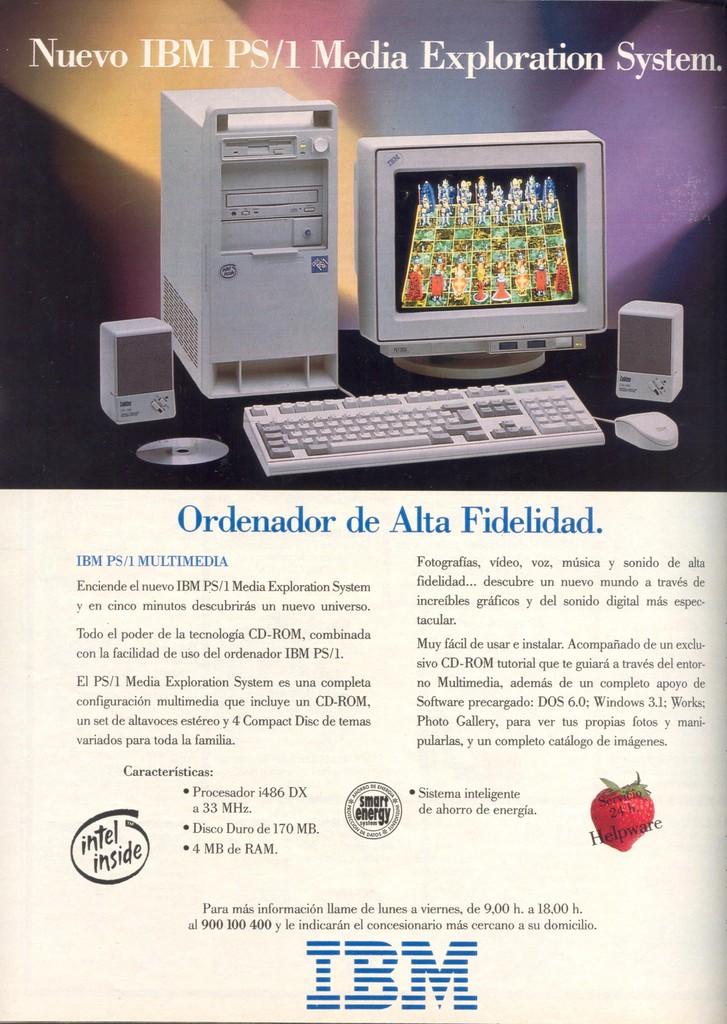What brand is this computer?
Offer a terse response. Ibm. What company put out this add?
Ensure brevity in your answer.  Ibm. 